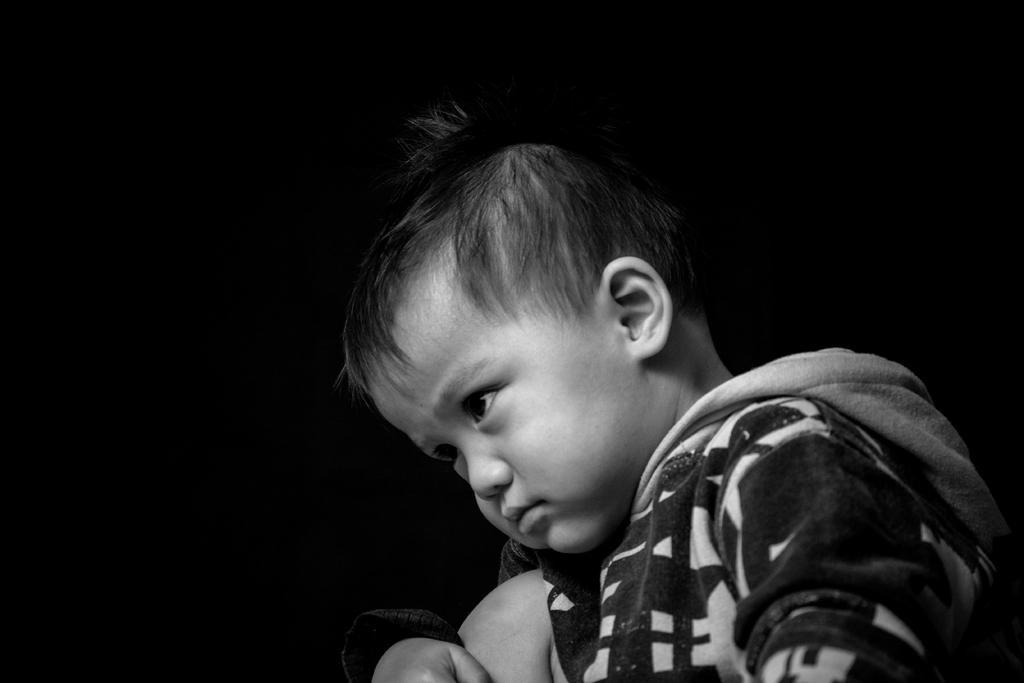Could you give a brief overview of what you see in this image? This is black and white image where we can see a boy. The background is dark. 